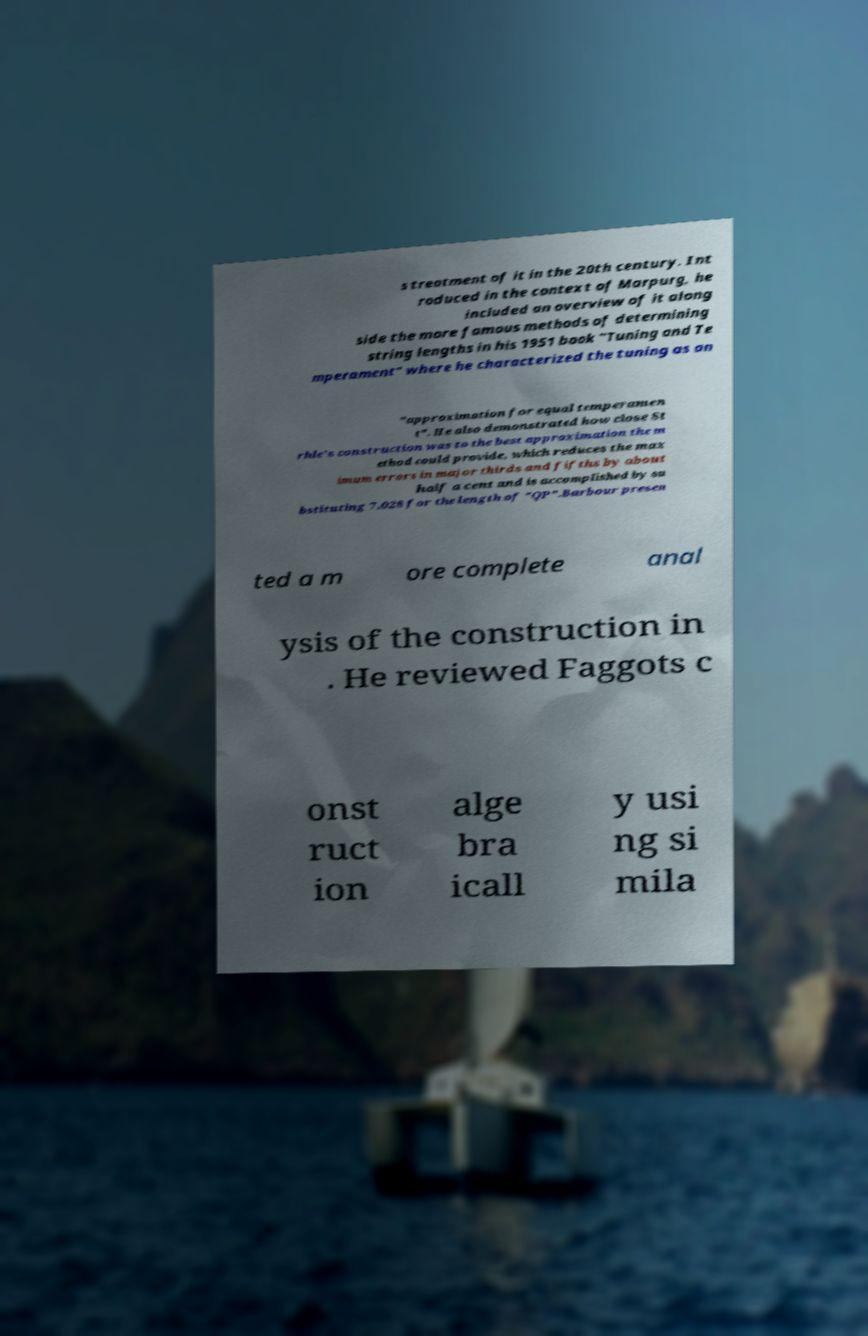What messages or text are displayed in this image? I need them in a readable, typed format. s treatment of it in the 20th century. Int roduced in the context of Marpurg, he included an overview of it along side the more famous methods of determining string lengths in his 1951 book "Tuning and Te mperament" where he characterized the tuning as an "approximation for equal temperamen t". He also demonstrated how close St rhle's construction was to the best approximation the m ethod could provide, which reduces the max imum errors in major thirds and fifths by about half a cent and is accomplished by su bstituting 7.028 for the length of "QP".Barbour presen ted a m ore complete anal ysis of the construction in . He reviewed Faggots c onst ruct ion alge bra icall y usi ng si mila 